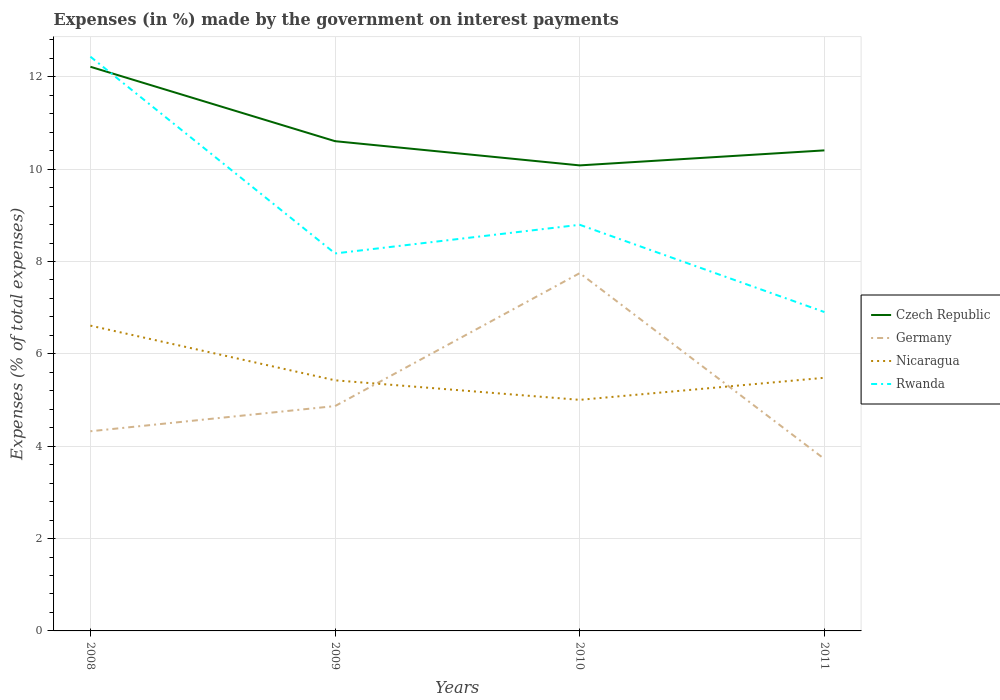How many different coloured lines are there?
Provide a succinct answer. 4. Is the number of lines equal to the number of legend labels?
Give a very brief answer. Yes. Across all years, what is the maximum percentage of expenses made by the government on interest payments in Germany?
Give a very brief answer. 3.72. What is the total percentage of expenses made by the government on interest payments in Nicaragua in the graph?
Keep it short and to the point. -0.05. What is the difference between the highest and the second highest percentage of expenses made by the government on interest payments in Nicaragua?
Give a very brief answer. 1.61. How many lines are there?
Make the answer very short. 4. What is the difference between two consecutive major ticks on the Y-axis?
Your answer should be compact. 2. Are the values on the major ticks of Y-axis written in scientific E-notation?
Your answer should be very brief. No. Does the graph contain any zero values?
Offer a very short reply. No. Does the graph contain grids?
Make the answer very short. Yes. How many legend labels are there?
Keep it short and to the point. 4. How are the legend labels stacked?
Offer a very short reply. Vertical. What is the title of the graph?
Your response must be concise. Expenses (in %) made by the government on interest payments. Does "High income: nonOECD" appear as one of the legend labels in the graph?
Keep it short and to the point. No. What is the label or title of the X-axis?
Your response must be concise. Years. What is the label or title of the Y-axis?
Offer a terse response. Expenses (% of total expenses). What is the Expenses (% of total expenses) of Czech Republic in 2008?
Keep it short and to the point. 12.22. What is the Expenses (% of total expenses) of Germany in 2008?
Your answer should be compact. 4.32. What is the Expenses (% of total expenses) of Nicaragua in 2008?
Give a very brief answer. 6.61. What is the Expenses (% of total expenses) of Rwanda in 2008?
Provide a short and direct response. 12.44. What is the Expenses (% of total expenses) in Czech Republic in 2009?
Offer a terse response. 10.61. What is the Expenses (% of total expenses) of Germany in 2009?
Give a very brief answer. 4.87. What is the Expenses (% of total expenses) of Nicaragua in 2009?
Give a very brief answer. 5.43. What is the Expenses (% of total expenses) in Rwanda in 2009?
Your answer should be compact. 8.17. What is the Expenses (% of total expenses) in Czech Republic in 2010?
Your response must be concise. 10.08. What is the Expenses (% of total expenses) in Germany in 2010?
Give a very brief answer. 7.75. What is the Expenses (% of total expenses) in Nicaragua in 2010?
Your answer should be compact. 5. What is the Expenses (% of total expenses) in Rwanda in 2010?
Your response must be concise. 8.8. What is the Expenses (% of total expenses) in Czech Republic in 2011?
Provide a short and direct response. 10.41. What is the Expenses (% of total expenses) of Germany in 2011?
Your answer should be compact. 3.72. What is the Expenses (% of total expenses) in Nicaragua in 2011?
Provide a succinct answer. 5.48. What is the Expenses (% of total expenses) of Rwanda in 2011?
Provide a succinct answer. 6.91. Across all years, what is the maximum Expenses (% of total expenses) of Czech Republic?
Offer a terse response. 12.22. Across all years, what is the maximum Expenses (% of total expenses) of Germany?
Your response must be concise. 7.75. Across all years, what is the maximum Expenses (% of total expenses) in Nicaragua?
Make the answer very short. 6.61. Across all years, what is the maximum Expenses (% of total expenses) of Rwanda?
Make the answer very short. 12.44. Across all years, what is the minimum Expenses (% of total expenses) of Czech Republic?
Offer a terse response. 10.08. Across all years, what is the minimum Expenses (% of total expenses) in Germany?
Your answer should be compact. 3.72. Across all years, what is the minimum Expenses (% of total expenses) in Nicaragua?
Provide a short and direct response. 5. Across all years, what is the minimum Expenses (% of total expenses) of Rwanda?
Keep it short and to the point. 6.91. What is the total Expenses (% of total expenses) in Czech Republic in the graph?
Your answer should be compact. 43.31. What is the total Expenses (% of total expenses) in Germany in the graph?
Offer a very short reply. 20.67. What is the total Expenses (% of total expenses) of Nicaragua in the graph?
Make the answer very short. 22.52. What is the total Expenses (% of total expenses) of Rwanda in the graph?
Provide a succinct answer. 36.31. What is the difference between the Expenses (% of total expenses) in Czech Republic in 2008 and that in 2009?
Your answer should be compact. 1.61. What is the difference between the Expenses (% of total expenses) of Germany in 2008 and that in 2009?
Your response must be concise. -0.55. What is the difference between the Expenses (% of total expenses) of Nicaragua in 2008 and that in 2009?
Your answer should be compact. 1.18. What is the difference between the Expenses (% of total expenses) of Rwanda in 2008 and that in 2009?
Ensure brevity in your answer.  4.26. What is the difference between the Expenses (% of total expenses) of Czech Republic in 2008 and that in 2010?
Your response must be concise. 2.14. What is the difference between the Expenses (% of total expenses) of Germany in 2008 and that in 2010?
Ensure brevity in your answer.  -3.42. What is the difference between the Expenses (% of total expenses) in Nicaragua in 2008 and that in 2010?
Ensure brevity in your answer.  1.61. What is the difference between the Expenses (% of total expenses) of Rwanda in 2008 and that in 2010?
Provide a succinct answer. 3.64. What is the difference between the Expenses (% of total expenses) in Czech Republic in 2008 and that in 2011?
Make the answer very short. 1.81. What is the difference between the Expenses (% of total expenses) of Germany in 2008 and that in 2011?
Make the answer very short. 0.6. What is the difference between the Expenses (% of total expenses) in Nicaragua in 2008 and that in 2011?
Your response must be concise. 1.13. What is the difference between the Expenses (% of total expenses) of Rwanda in 2008 and that in 2011?
Offer a terse response. 5.53. What is the difference between the Expenses (% of total expenses) in Czech Republic in 2009 and that in 2010?
Keep it short and to the point. 0.52. What is the difference between the Expenses (% of total expenses) of Germany in 2009 and that in 2010?
Provide a succinct answer. -2.88. What is the difference between the Expenses (% of total expenses) in Nicaragua in 2009 and that in 2010?
Your response must be concise. 0.42. What is the difference between the Expenses (% of total expenses) of Rwanda in 2009 and that in 2010?
Give a very brief answer. -0.62. What is the difference between the Expenses (% of total expenses) in Czech Republic in 2009 and that in 2011?
Give a very brief answer. 0.2. What is the difference between the Expenses (% of total expenses) of Germany in 2009 and that in 2011?
Offer a terse response. 1.15. What is the difference between the Expenses (% of total expenses) in Nicaragua in 2009 and that in 2011?
Keep it short and to the point. -0.05. What is the difference between the Expenses (% of total expenses) of Rwanda in 2009 and that in 2011?
Offer a terse response. 1.27. What is the difference between the Expenses (% of total expenses) of Czech Republic in 2010 and that in 2011?
Provide a succinct answer. -0.33. What is the difference between the Expenses (% of total expenses) in Germany in 2010 and that in 2011?
Keep it short and to the point. 4.02. What is the difference between the Expenses (% of total expenses) of Nicaragua in 2010 and that in 2011?
Offer a very short reply. -0.48. What is the difference between the Expenses (% of total expenses) in Rwanda in 2010 and that in 2011?
Your answer should be very brief. 1.89. What is the difference between the Expenses (% of total expenses) of Czech Republic in 2008 and the Expenses (% of total expenses) of Germany in 2009?
Provide a succinct answer. 7.35. What is the difference between the Expenses (% of total expenses) in Czech Republic in 2008 and the Expenses (% of total expenses) in Nicaragua in 2009?
Make the answer very short. 6.79. What is the difference between the Expenses (% of total expenses) in Czech Republic in 2008 and the Expenses (% of total expenses) in Rwanda in 2009?
Offer a very short reply. 4.04. What is the difference between the Expenses (% of total expenses) in Germany in 2008 and the Expenses (% of total expenses) in Nicaragua in 2009?
Keep it short and to the point. -1.1. What is the difference between the Expenses (% of total expenses) in Germany in 2008 and the Expenses (% of total expenses) in Rwanda in 2009?
Provide a succinct answer. -3.85. What is the difference between the Expenses (% of total expenses) of Nicaragua in 2008 and the Expenses (% of total expenses) of Rwanda in 2009?
Provide a succinct answer. -1.56. What is the difference between the Expenses (% of total expenses) in Czech Republic in 2008 and the Expenses (% of total expenses) in Germany in 2010?
Your answer should be very brief. 4.47. What is the difference between the Expenses (% of total expenses) of Czech Republic in 2008 and the Expenses (% of total expenses) of Nicaragua in 2010?
Provide a succinct answer. 7.21. What is the difference between the Expenses (% of total expenses) in Czech Republic in 2008 and the Expenses (% of total expenses) in Rwanda in 2010?
Give a very brief answer. 3.42. What is the difference between the Expenses (% of total expenses) of Germany in 2008 and the Expenses (% of total expenses) of Nicaragua in 2010?
Provide a succinct answer. -0.68. What is the difference between the Expenses (% of total expenses) in Germany in 2008 and the Expenses (% of total expenses) in Rwanda in 2010?
Provide a succinct answer. -4.47. What is the difference between the Expenses (% of total expenses) in Nicaragua in 2008 and the Expenses (% of total expenses) in Rwanda in 2010?
Ensure brevity in your answer.  -2.18. What is the difference between the Expenses (% of total expenses) of Czech Republic in 2008 and the Expenses (% of total expenses) of Germany in 2011?
Give a very brief answer. 8.49. What is the difference between the Expenses (% of total expenses) in Czech Republic in 2008 and the Expenses (% of total expenses) in Nicaragua in 2011?
Make the answer very short. 6.74. What is the difference between the Expenses (% of total expenses) of Czech Republic in 2008 and the Expenses (% of total expenses) of Rwanda in 2011?
Offer a terse response. 5.31. What is the difference between the Expenses (% of total expenses) in Germany in 2008 and the Expenses (% of total expenses) in Nicaragua in 2011?
Your answer should be very brief. -1.16. What is the difference between the Expenses (% of total expenses) of Germany in 2008 and the Expenses (% of total expenses) of Rwanda in 2011?
Ensure brevity in your answer.  -2.58. What is the difference between the Expenses (% of total expenses) of Nicaragua in 2008 and the Expenses (% of total expenses) of Rwanda in 2011?
Offer a very short reply. -0.29. What is the difference between the Expenses (% of total expenses) in Czech Republic in 2009 and the Expenses (% of total expenses) in Germany in 2010?
Keep it short and to the point. 2.86. What is the difference between the Expenses (% of total expenses) in Czech Republic in 2009 and the Expenses (% of total expenses) in Nicaragua in 2010?
Keep it short and to the point. 5.6. What is the difference between the Expenses (% of total expenses) of Czech Republic in 2009 and the Expenses (% of total expenses) of Rwanda in 2010?
Your answer should be very brief. 1.81. What is the difference between the Expenses (% of total expenses) of Germany in 2009 and the Expenses (% of total expenses) of Nicaragua in 2010?
Your response must be concise. -0.13. What is the difference between the Expenses (% of total expenses) in Germany in 2009 and the Expenses (% of total expenses) in Rwanda in 2010?
Make the answer very short. -3.93. What is the difference between the Expenses (% of total expenses) of Nicaragua in 2009 and the Expenses (% of total expenses) of Rwanda in 2010?
Offer a terse response. -3.37. What is the difference between the Expenses (% of total expenses) in Czech Republic in 2009 and the Expenses (% of total expenses) in Germany in 2011?
Your answer should be compact. 6.88. What is the difference between the Expenses (% of total expenses) of Czech Republic in 2009 and the Expenses (% of total expenses) of Nicaragua in 2011?
Give a very brief answer. 5.12. What is the difference between the Expenses (% of total expenses) of Czech Republic in 2009 and the Expenses (% of total expenses) of Rwanda in 2011?
Keep it short and to the point. 3.7. What is the difference between the Expenses (% of total expenses) in Germany in 2009 and the Expenses (% of total expenses) in Nicaragua in 2011?
Keep it short and to the point. -0.61. What is the difference between the Expenses (% of total expenses) in Germany in 2009 and the Expenses (% of total expenses) in Rwanda in 2011?
Offer a terse response. -2.04. What is the difference between the Expenses (% of total expenses) of Nicaragua in 2009 and the Expenses (% of total expenses) of Rwanda in 2011?
Your response must be concise. -1.48. What is the difference between the Expenses (% of total expenses) in Czech Republic in 2010 and the Expenses (% of total expenses) in Germany in 2011?
Offer a very short reply. 6.36. What is the difference between the Expenses (% of total expenses) of Czech Republic in 2010 and the Expenses (% of total expenses) of Nicaragua in 2011?
Give a very brief answer. 4.6. What is the difference between the Expenses (% of total expenses) of Czech Republic in 2010 and the Expenses (% of total expenses) of Rwanda in 2011?
Provide a succinct answer. 3.18. What is the difference between the Expenses (% of total expenses) in Germany in 2010 and the Expenses (% of total expenses) in Nicaragua in 2011?
Give a very brief answer. 2.27. What is the difference between the Expenses (% of total expenses) in Germany in 2010 and the Expenses (% of total expenses) in Rwanda in 2011?
Offer a terse response. 0.84. What is the difference between the Expenses (% of total expenses) of Nicaragua in 2010 and the Expenses (% of total expenses) of Rwanda in 2011?
Your answer should be compact. -1.9. What is the average Expenses (% of total expenses) of Czech Republic per year?
Offer a terse response. 10.83. What is the average Expenses (% of total expenses) in Germany per year?
Provide a succinct answer. 5.17. What is the average Expenses (% of total expenses) in Nicaragua per year?
Provide a succinct answer. 5.63. What is the average Expenses (% of total expenses) of Rwanda per year?
Keep it short and to the point. 9.08. In the year 2008, what is the difference between the Expenses (% of total expenses) of Czech Republic and Expenses (% of total expenses) of Germany?
Make the answer very short. 7.89. In the year 2008, what is the difference between the Expenses (% of total expenses) of Czech Republic and Expenses (% of total expenses) of Nicaragua?
Offer a very short reply. 5.61. In the year 2008, what is the difference between the Expenses (% of total expenses) of Czech Republic and Expenses (% of total expenses) of Rwanda?
Give a very brief answer. -0.22. In the year 2008, what is the difference between the Expenses (% of total expenses) of Germany and Expenses (% of total expenses) of Nicaragua?
Ensure brevity in your answer.  -2.29. In the year 2008, what is the difference between the Expenses (% of total expenses) in Germany and Expenses (% of total expenses) in Rwanda?
Offer a terse response. -8.11. In the year 2008, what is the difference between the Expenses (% of total expenses) of Nicaragua and Expenses (% of total expenses) of Rwanda?
Ensure brevity in your answer.  -5.82. In the year 2009, what is the difference between the Expenses (% of total expenses) in Czech Republic and Expenses (% of total expenses) in Germany?
Ensure brevity in your answer.  5.74. In the year 2009, what is the difference between the Expenses (% of total expenses) in Czech Republic and Expenses (% of total expenses) in Nicaragua?
Provide a succinct answer. 5.18. In the year 2009, what is the difference between the Expenses (% of total expenses) in Czech Republic and Expenses (% of total expenses) in Rwanda?
Make the answer very short. 2.43. In the year 2009, what is the difference between the Expenses (% of total expenses) in Germany and Expenses (% of total expenses) in Nicaragua?
Your answer should be compact. -0.56. In the year 2009, what is the difference between the Expenses (% of total expenses) in Germany and Expenses (% of total expenses) in Rwanda?
Offer a terse response. -3.31. In the year 2009, what is the difference between the Expenses (% of total expenses) in Nicaragua and Expenses (% of total expenses) in Rwanda?
Ensure brevity in your answer.  -2.75. In the year 2010, what is the difference between the Expenses (% of total expenses) of Czech Republic and Expenses (% of total expenses) of Germany?
Offer a terse response. 2.33. In the year 2010, what is the difference between the Expenses (% of total expenses) of Czech Republic and Expenses (% of total expenses) of Nicaragua?
Keep it short and to the point. 5.08. In the year 2010, what is the difference between the Expenses (% of total expenses) of Czech Republic and Expenses (% of total expenses) of Rwanda?
Your answer should be very brief. 1.29. In the year 2010, what is the difference between the Expenses (% of total expenses) of Germany and Expenses (% of total expenses) of Nicaragua?
Offer a terse response. 2.74. In the year 2010, what is the difference between the Expenses (% of total expenses) in Germany and Expenses (% of total expenses) in Rwanda?
Your answer should be compact. -1.05. In the year 2010, what is the difference between the Expenses (% of total expenses) in Nicaragua and Expenses (% of total expenses) in Rwanda?
Your answer should be very brief. -3.79. In the year 2011, what is the difference between the Expenses (% of total expenses) in Czech Republic and Expenses (% of total expenses) in Germany?
Ensure brevity in your answer.  6.68. In the year 2011, what is the difference between the Expenses (% of total expenses) of Czech Republic and Expenses (% of total expenses) of Nicaragua?
Offer a terse response. 4.92. In the year 2011, what is the difference between the Expenses (% of total expenses) of Czech Republic and Expenses (% of total expenses) of Rwanda?
Your answer should be very brief. 3.5. In the year 2011, what is the difference between the Expenses (% of total expenses) in Germany and Expenses (% of total expenses) in Nicaragua?
Provide a succinct answer. -1.76. In the year 2011, what is the difference between the Expenses (% of total expenses) of Germany and Expenses (% of total expenses) of Rwanda?
Make the answer very short. -3.18. In the year 2011, what is the difference between the Expenses (% of total expenses) of Nicaragua and Expenses (% of total expenses) of Rwanda?
Make the answer very short. -1.42. What is the ratio of the Expenses (% of total expenses) in Czech Republic in 2008 to that in 2009?
Your answer should be compact. 1.15. What is the ratio of the Expenses (% of total expenses) in Germany in 2008 to that in 2009?
Offer a terse response. 0.89. What is the ratio of the Expenses (% of total expenses) of Nicaragua in 2008 to that in 2009?
Your response must be concise. 1.22. What is the ratio of the Expenses (% of total expenses) in Rwanda in 2008 to that in 2009?
Provide a succinct answer. 1.52. What is the ratio of the Expenses (% of total expenses) in Czech Republic in 2008 to that in 2010?
Give a very brief answer. 1.21. What is the ratio of the Expenses (% of total expenses) of Germany in 2008 to that in 2010?
Your answer should be compact. 0.56. What is the ratio of the Expenses (% of total expenses) in Nicaragua in 2008 to that in 2010?
Provide a short and direct response. 1.32. What is the ratio of the Expenses (% of total expenses) of Rwanda in 2008 to that in 2010?
Keep it short and to the point. 1.41. What is the ratio of the Expenses (% of total expenses) in Czech Republic in 2008 to that in 2011?
Give a very brief answer. 1.17. What is the ratio of the Expenses (% of total expenses) of Germany in 2008 to that in 2011?
Keep it short and to the point. 1.16. What is the ratio of the Expenses (% of total expenses) of Nicaragua in 2008 to that in 2011?
Provide a succinct answer. 1.21. What is the ratio of the Expenses (% of total expenses) in Rwanda in 2008 to that in 2011?
Provide a succinct answer. 1.8. What is the ratio of the Expenses (% of total expenses) of Czech Republic in 2009 to that in 2010?
Keep it short and to the point. 1.05. What is the ratio of the Expenses (% of total expenses) of Germany in 2009 to that in 2010?
Give a very brief answer. 0.63. What is the ratio of the Expenses (% of total expenses) of Nicaragua in 2009 to that in 2010?
Your answer should be very brief. 1.08. What is the ratio of the Expenses (% of total expenses) of Rwanda in 2009 to that in 2010?
Your answer should be compact. 0.93. What is the ratio of the Expenses (% of total expenses) of Czech Republic in 2009 to that in 2011?
Your answer should be very brief. 1.02. What is the ratio of the Expenses (% of total expenses) in Germany in 2009 to that in 2011?
Your answer should be very brief. 1.31. What is the ratio of the Expenses (% of total expenses) in Rwanda in 2009 to that in 2011?
Provide a succinct answer. 1.18. What is the ratio of the Expenses (% of total expenses) of Czech Republic in 2010 to that in 2011?
Keep it short and to the point. 0.97. What is the ratio of the Expenses (% of total expenses) in Germany in 2010 to that in 2011?
Your answer should be compact. 2.08. What is the ratio of the Expenses (% of total expenses) of Nicaragua in 2010 to that in 2011?
Your answer should be compact. 0.91. What is the ratio of the Expenses (% of total expenses) in Rwanda in 2010 to that in 2011?
Give a very brief answer. 1.27. What is the difference between the highest and the second highest Expenses (% of total expenses) of Czech Republic?
Ensure brevity in your answer.  1.61. What is the difference between the highest and the second highest Expenses (% of total expenses) in Germany?
Ensure brevity in your answer.  2.88. What is the difference between the highest and the second highest Expenses (% of total expenses) in Nicaragua?
Ensure brevity in your answer.  1.13. What is the difference between the highest and the second highest Expenses (% of total expenses) of Rwanda?
Your answer should be compact. 3.64. What is the difference between the highest and the lowest Expenses (% of total expenses) in Czech Republic?
Your answer should be very brief. 2.14. What is the difference between the highest and the lowest Expenses (% of total expenses) of Germany?
Give a very brief answer. 4.02. What is the difference between the highest and the lowest Expenses (% of total expenses) in Nicaragua?
Give a very brief answer. 1.61. What is the difference between the highest and the lowest Expenses (% of total expenses) in Rwanda?
Your response must be concise. 5.53. 